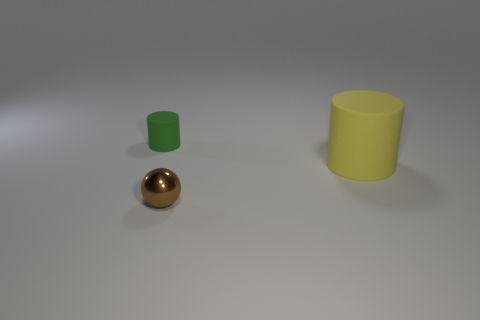Add 3 small cyan objects. How many objects exist? 6 Subtract all cylinders. How many objects are left? 1 Subtract all cyan rubber cylinders. Subtract all green matte cylinders. How many objects are left? 2 Add 2 shiny balls. How many shiny balls are left? 3 Add 3 small brown metal objects. How many small brown metal objects exist? 4 Subtract 0 blue spheres. How many objects are left? 3 